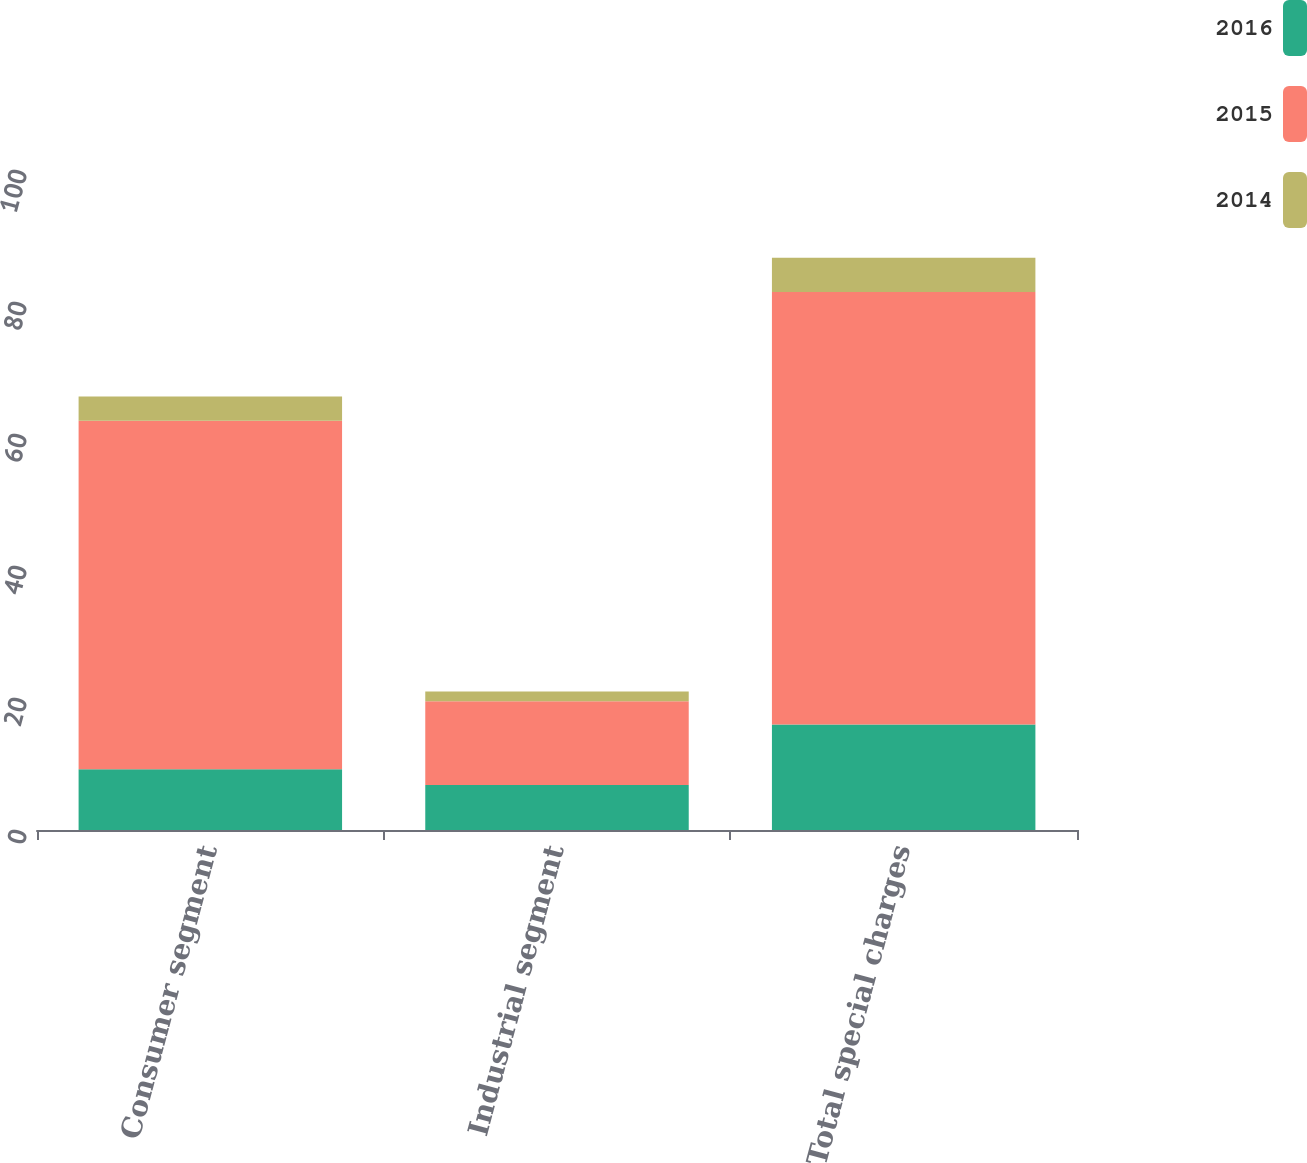<chart> <loc_0><loc_0><loc_500><loc_500><stacked_bar_chart><ecel><fcel>Consumer segment<fcel>Industrial segment<fcel>Total special charges<nl><fcel>2016<fcel>9.2<fcel>6.8<fcel>16<nl><fcel>2015<fcel>52.8<fcel>12.7<fcel>65.5<nl><fcel>2014<fcel>3.7<fcel>1.5<fcel>5.2<nl></chart> 